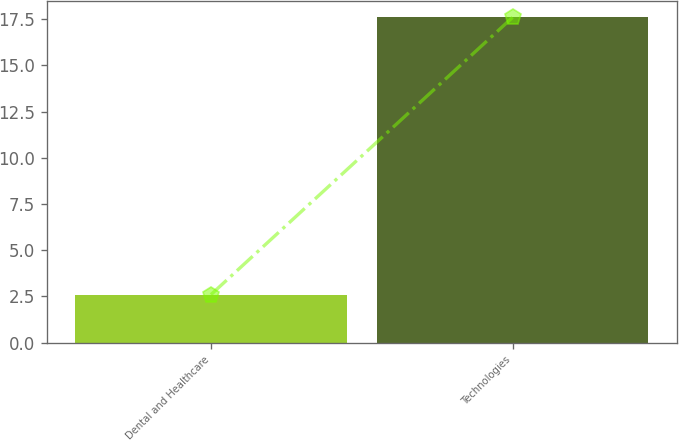Convert chart. <chart><loc_0><loc_0><loc_500><loc_500><bar_chart><fcel>Dental and Healthcare<fcel>Technologies<nl><fcel>2.6<fcel>17.6<nl></chart> 